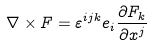<formula> <loc_0><loc_0><loc_500><loc_500>\nabla \times F = \varepsilon ^ { i j k } e _ { i } { \frac { \partial F _ { k } } { \partial x ^ { j } } }</formula> 